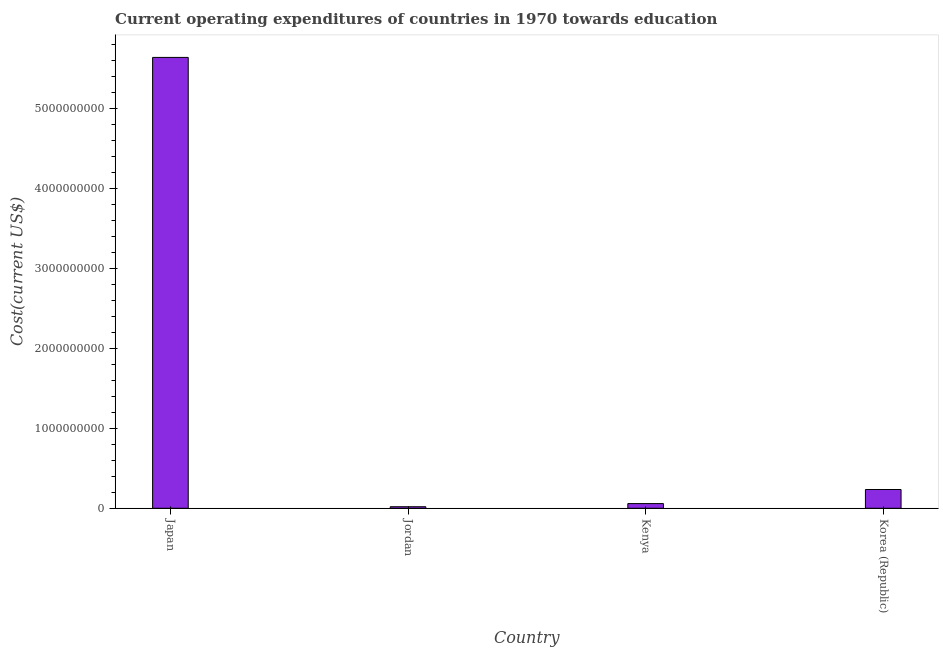Does the graph contain any zero values?
Offer a very short reply. No. What is the title of the graph?
Your answer should be compact. Current operating expenditures of countries in 1970 towards education. What is the label or title of the X-axis?
Provide a succinct answer. Country. What is the label or title of the Y-axis?
Offer a very short reply. Cost(current US$). What is the education expenditure in Kenya?
Your answer should be compact. 5.85e+07. Across all countries, what is the maximum education expenditure?
Your answer should be very brief. 5.63e+09. Across all countries, what is the minimum education expenditure?
Make the answer very short. 1.91e+07. In which country was the education expenditure minimum?
Your response must be concise. Jordan. What is the sum of the education expenditure?
Your answer should be very brief. 5.95e+09. What is the difference between the education expenditure in Jordan and Korea (Republic)?
Provide a succinct answer. -2.15e+08. What is the average education expenditure per country?
Your answer should be very brief. 1.49e+09. What is the median education expenditure?
Provide a succinct answer. 1.46e+08. In how many countries, is the education expenditure greater than 800000000 US$?
Offer a terse response. 1. What is the ratio of the education expenditure in Japan to that in Kenya?
Ensure brevity in your answer.  96.35. Is the education expenditure in Jordan less than that in Kenya?
Provide a short and direct response. Yes. Is the difference between the education expenditure in Kenya and Korea (Republic) greater than the difference between any two countries?
Ensure brevity in your answer.  No. What is the difference between the highest and the second highest education expenditure?
Your answer should be compact. 5.40e+09. What is the difference between the highest and the lowest education expenditure?
Your answer should be very brief. 5.62e+09. In how many countries, is the education expenditure greater than the average education expenditure taken over all countries?
Keep it short and to the point. 1. What is the difference between two consecutive major ticks on the Y-axis?
Offer a very short reply. 1.00e+09. Are the values on the major ticks of Y-axis written in scientific E-notation?
Your response must be concise. No. What is the Cost(current US$) of Japan?
Your answer should be very brief. 5.63e+09. What is the Cost(current US$) of Jordan?
Ensure brevity in your answer.  1.91e+07. What is the Cost(current US$) in Kenya?
Your answer should be compact. 5.85e+07. What is the Cost(current US$) in Korea (Republic)?
Offer a very short reply. 2.34e+08. What is the difference between the Cost(current US$) in Japan and Jordan?
Offer a terse response. 5.62e+09. What is the difference between the Cost(current US$) in Japan and Kenya?
Offer a terse response. 5.58e+09. What is the difference between the Cost(current US$) in Japan and Korea (Republic)?
Offer a terse response. 5.40e+09. What is the difference between the Cost(current US$) in Jordan and Kenya?
Provide a succinct answer. -3.94e+07. What is the difference between the Cost(current US$) in Jordan and Korea (Republic)?
Provide a short and direct response. -2.15e+08. What is the difference between the Cost(current US$) in Kenya and Korea (Republic)?
Provide a short and direct response. -1.76e+08. What is the ratio of the Cost(current US$) in Japan to that in Jordan?
Provide a succinct answer. 295.14. What is the ratio of the Cost(current US$) in Japan to that in Kenya?
Your answer should be very brief. 96.35. What is the ratio of the Cost(current US$) in Japan to that in Korea (Republic)?
Give a very brief answer. 24.03. What is the ratio of the Cost(current US$) in Jordan to that in Kenya?
Give a very brief answer. 0.33. What is the ratio of the Cost(current US$) in Jordan to that in Korea (Republic)?
Your answer should be compact. 0.08. What is the ratio of the Cost(current US$) in Kenya to that in Korea (Republic)?
Ensure brevity in your answer.  0.25. 